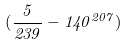<formula> <loc_0><loc_0><loc_500><loc_500>( \frac { 5 } { 2 3 9 } - 1 4 0 ^ { 2 0 7 } )</formula> 